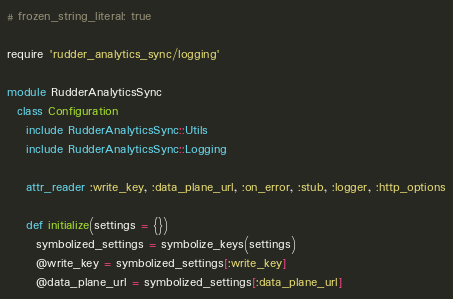<code> <loc_0><loc_0><loc_500><loc_500><_Ruby_># frozen_string_literal: true

require 'rudder_analytics_sync/logging'

module RudderAnalyticsSync
  class Configuration
    include RudderAnalyticsSync::Utils
    include RudderAnalyticsSync::Logging

    attr_reader :write_key, :data_plane_url, :on_error, :stub, :logger, :http_options

    def initialize(settings = {})
      symbolized_settings = symbolize_keys(settings)
      @write_key = symbolized_settings[:write_key]
      @data_plane_url = symbolized_settings[:data_plane_url]</code> 